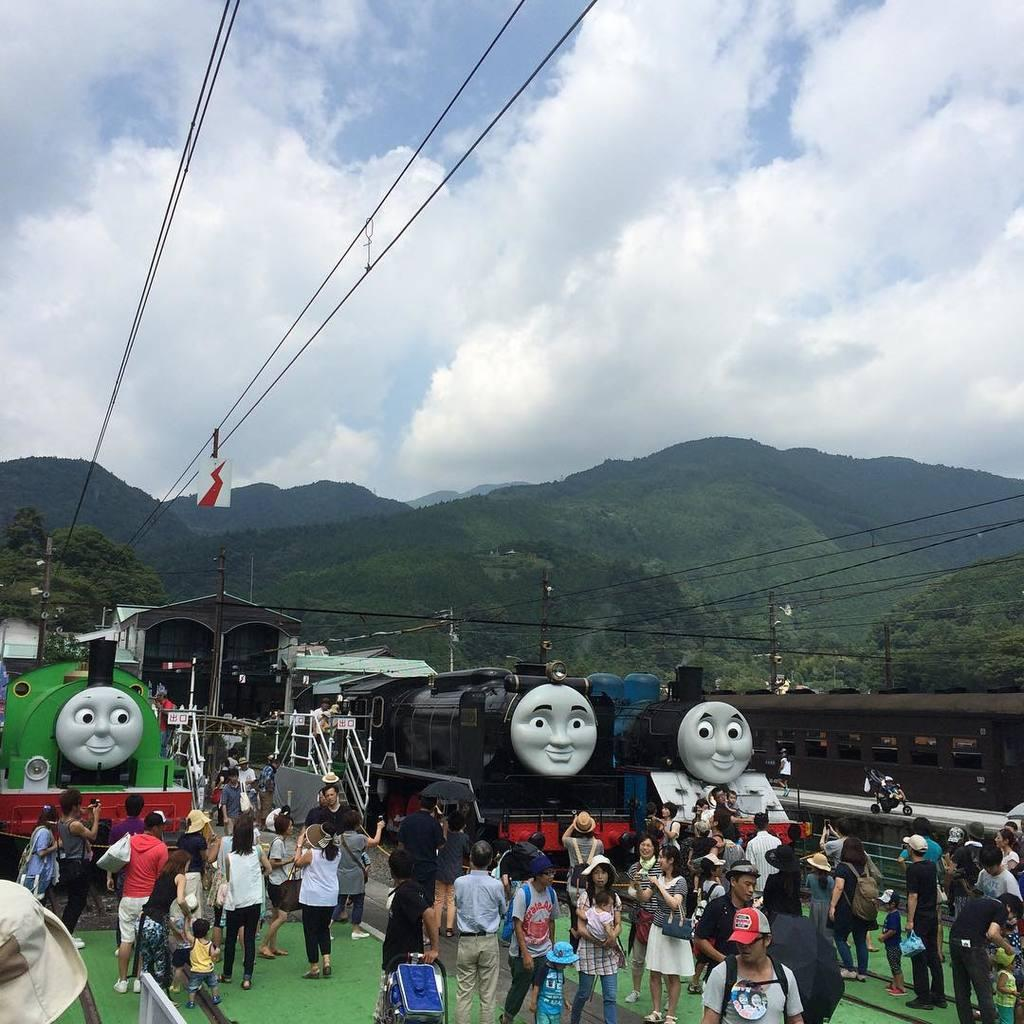What type of natural formation can be seen in the background of the image? There are mountains in the background of the image. What is visible at the top of the image? The sky is visible at the top of the image. What can be observed in the sky? Clouds are present in the sky. What mode of transportation can be seen in the image? There are trains in the image. Are there any people visible in the image? Yes, there are people in the image. Can you see any dinosaurs in the image? No, there are no dinosaurs present in the image. What color is the wrist of the person in the image? There is no specific wrist mentioned in the image, and it is not possible to determine the color of a wrist without more information. 